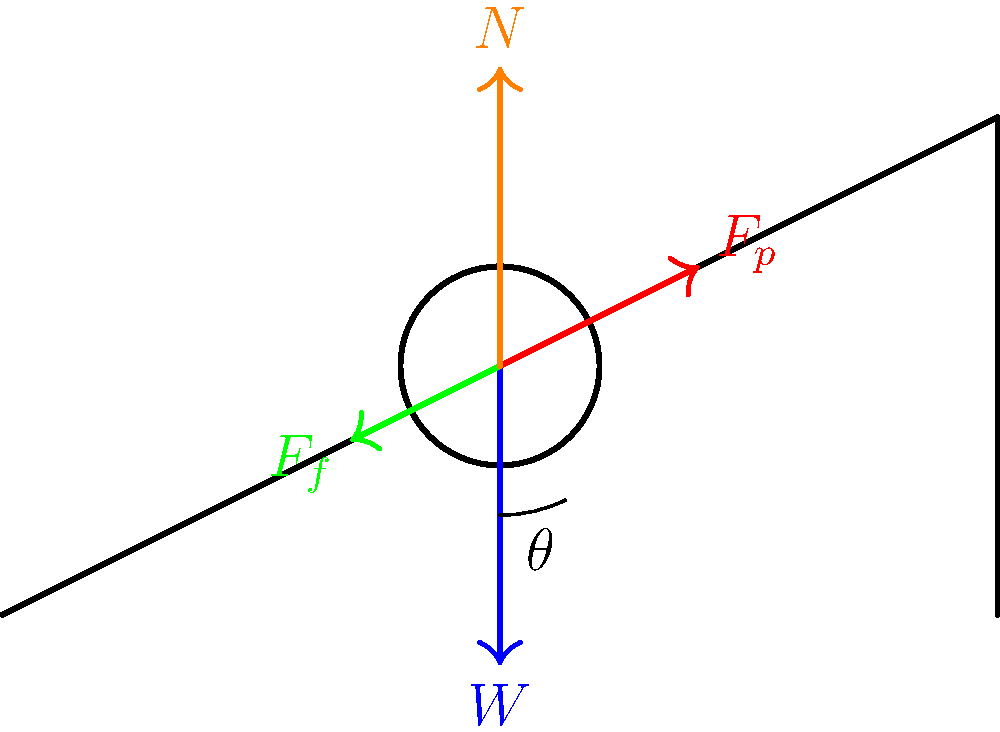A cyclist is riding uphill at a constant speed. The force diagram shows four forces acting on the cyclist: weight ($W$), pedal force ($F_p$), friction ($F_f$), and normal force ($N$). If the angle of the hill is $\theta$, what is the relationship between the pedal force and the component of the weight parallel to the slope? To solve this problem, let's follow these steps:

1. Identify the forces acting parallel to the slope:
   - Component of weight parallel to the slope: $W \sin(\theta)$
   - Pedal force: $F_p$
   - Friction force: $F_f$

2. Since the cyclist is moving at constant speed, the net force parallel to the slope must be zero (Newton's First Law):

   $$F_p - W \sin(\theta) - F_f = 0$$

3. Rearrange the equation to isolate $F_p$:

   $$F_p = W \sin(\theta) + F_f$$

4. This equation shows that the pedal force must overcome both the component of weight parallel to the slope and the friction force to maintain constant speed.

5. The relationship between $F_p$ and $W \sin(\theta)$ is:

   $$F_p > W \sin(\theta)$$

   This is because $F_p$ must also overcome friction ($F_f$), which is always positive in this scenario.
Answer: $F_p > W \sin(\theta)$ 